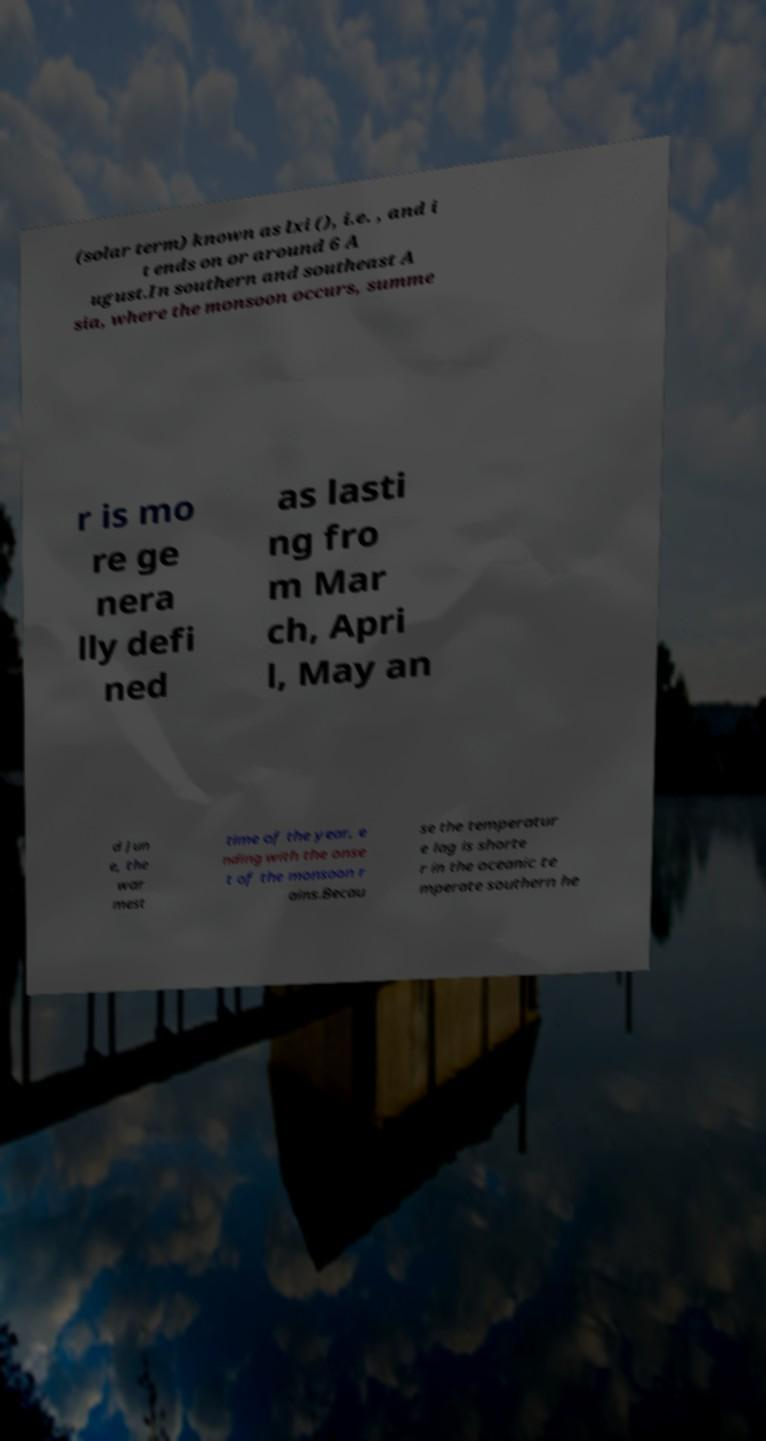For documentation purposes, I need the text within this image transcribed. Could you provide that? (solar term) known as lxi (), i.e. , and i t ends on or around 6 A ugust.In southern and southeast A sia, where the monsoon occurs, summe r is mo re ge nera lly defi ned as lasti ng fro m Mar ch, Apri l, May an d Jun e, the war mest time of the year, e nding with the onse t of the monsoon r ains.Becau se the temperatur e lag is shorte r in the oceanic te mperate southern he 